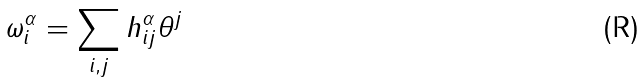<formula> <loc_0><loc_0><loc_500><loc_500>\omega ^ { \alpha } _ { i } = \sum _ { i , j } h ^ { \alpha } _ { i j } \theta ^ { j }</formula> 